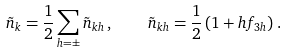<formula> <loc_0><loc_0><loc_500><loc_500>\tilde { n } _ { k } = \frac { 1 } { 2 } \sum _ { h = \pm } \tilde { n } _ { k h } \, , \quad \tilde { n } _ { k h } = \frac { 1 } { 2 } \left ( 1 + h f _ { 3 h } \right ) \, .</formula> 